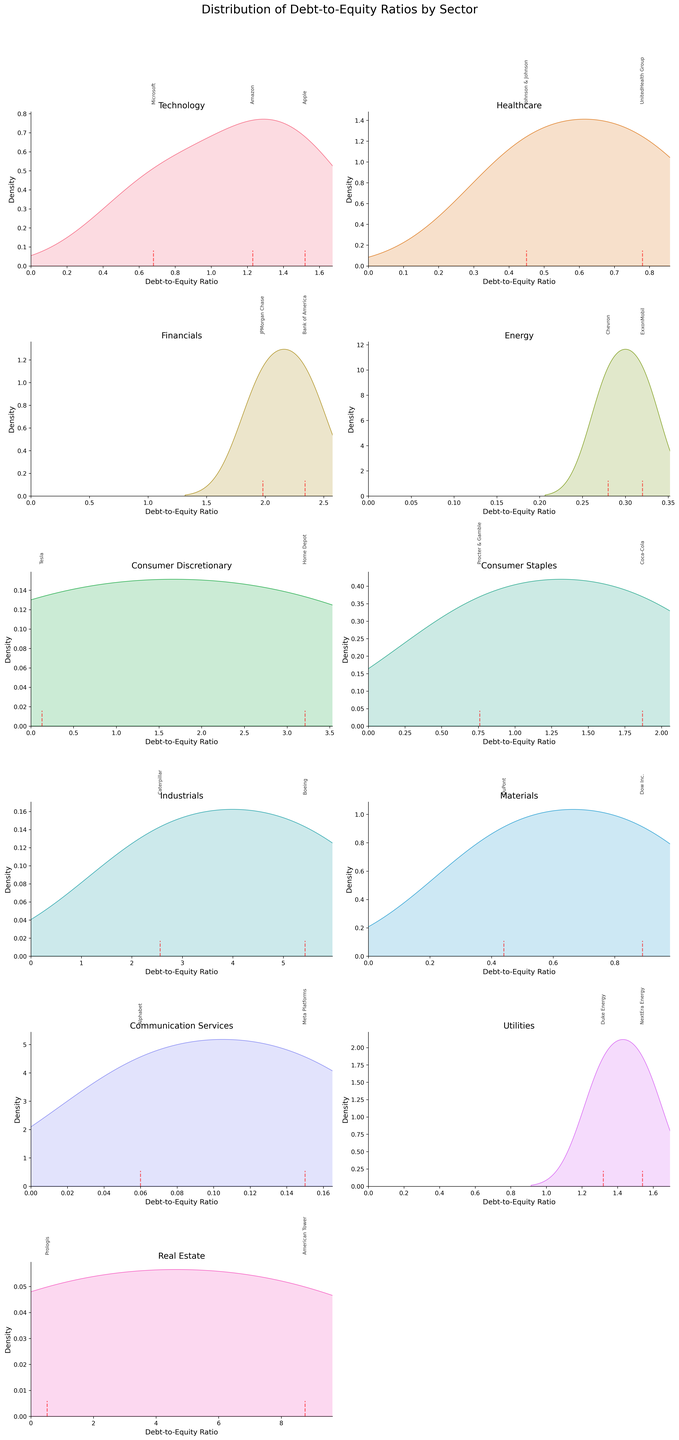What is the title of the figure? The title of the figure is displayed at the top of the figure, summarizing the content of the figure. It helps in understanding what aspects of the data are being visualized.
Answer: Distribution of Debt-to-Equity Ratios by Sector Which sector has the company with the highest debt-to-equity ratio? Among the density plots, the Real Estate sector has a company, American Tower, with the highest debt-to-equity ratio marked by a vertical red dashed line near 8.76.
Answer: Real Estate Which sector contains companies with the lowest debt-to-equity ratios in their sector? By examining the vertical red dashed lines, the Communication Services sector contains companies with the lowest debt-to-equity ratios, specifically Alphabet with 0.06 and Meta Platforms with 0.15.
Answer: Communication Services What value has the peak density for the Industrial sector? The peak of the density plot in the Industrial sector occurs around the highest density point where the plot reaches its maximum height.
Answer: Approximately 5.43 How does the debt-to-equity ratio of Amazon compare to that of Apple? By comparing the vertical red dashed lines in the Technology sector plot, Amazon has a debt-to-equity ratio of 1.23, while Apple has a ratio of 1.52, making Amazon's ratio lower.
Answer: Amazon's ratio is lower than Apple's Which sectors have the most dispersed debt-to-equity ratios? The dispersion of debt-to-equity ratios is indicated by the spread of the density plots. For the Real Estate sector, the plot is wide-ranging from near 0 to almost 9, indicating high dispersion.
Answer: Real Estate What is the average debt-to-equity ratio for the Consumer Staples sector? Considering the two companies in the Consumer Staples sector, Procter & Gamble (0.76) and Coca-Cola (1.87), the average is calculated as (0.76 + 1.87) / 2 = 1.315.
Answer: 1.315 Which sector has a company with a debt-to-equity ratio very close to the sector's average? The Healthcare sector, with Johnson & Johnson having a ratio of 0.45 and UnitedHealth Group with 0.78, has these data points relatively close to the sector's average (0.615).
Answer: Healthcare What is unique about the Energy sector's debt-to-equity ratios? The Energy sector's density plot shows low debt-to-equity ratios for both companies, ExxonMobil (0.32) and Chevron (0.28), indicating they have minimal debt compared to equity.
Answer: Low Debt-to-Equity Which sectors have only one company with significantly high debt-to-equity ratios? The Industrial sector, with Boeing having a debt-to-equity ratio of 5.43, stands out as having only one company with a significantly high ratio.
Answer: Industrials 